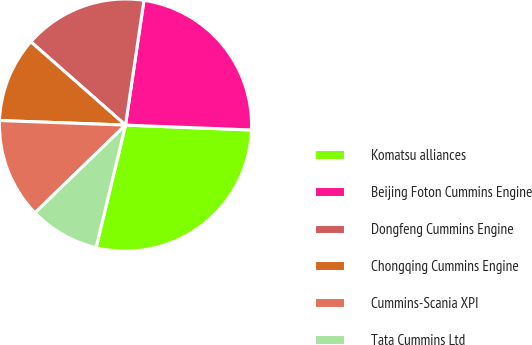Convert chart. <chart><loc_0><loc_0><loc_500><loc_500><pie_chart><fcel>Komatsu alliances<fcel>Beijing Foton Cummins Engine<fcel>Dongfeng Cummins Engine<fcel>Chongqing Cummins Engine<fcel>Cummins-Scania XPI<fcel>Tata Cummins Ltd<nl><fcel>28.13%<fcel>23.28%<fcel>15.85%<fcel>10.91%<fcel>12.82%<fcel>9.0%<nl></chart> 